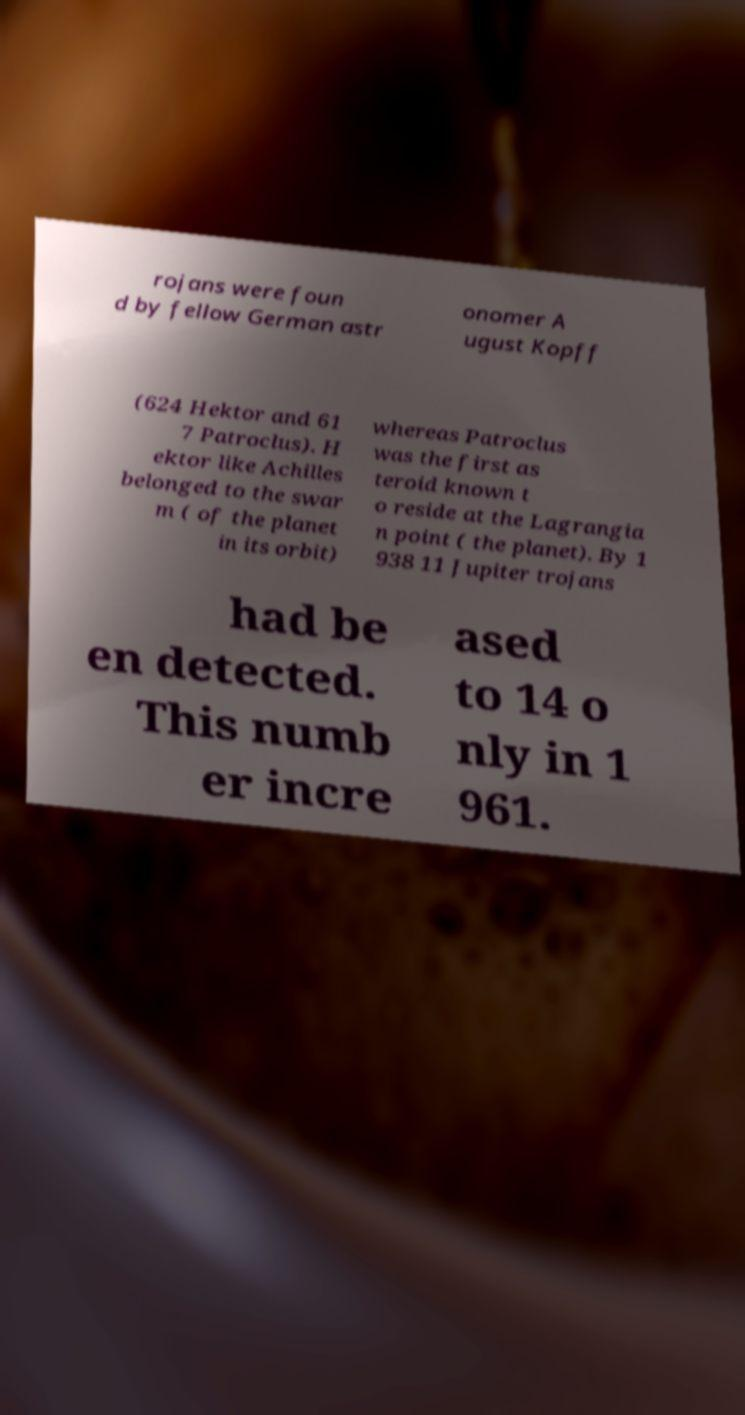There's text embedded in this image that I need extracted. Can you transcribe it verbatim? rojans were foun d by fellow German astr onomer A ugust Kopff (624 Hektor and 61 7 Patroclus). H ektor like Achilles belonged to the swar m ( of the planet in its orbit) whereas Patroclus was the first as teroid known t o reside at the Lagrangia n point ( the planet). By 1 938 11 Jupiter trojans had be en detected. This numb er incre ased to 14 o nly in 1 961. 